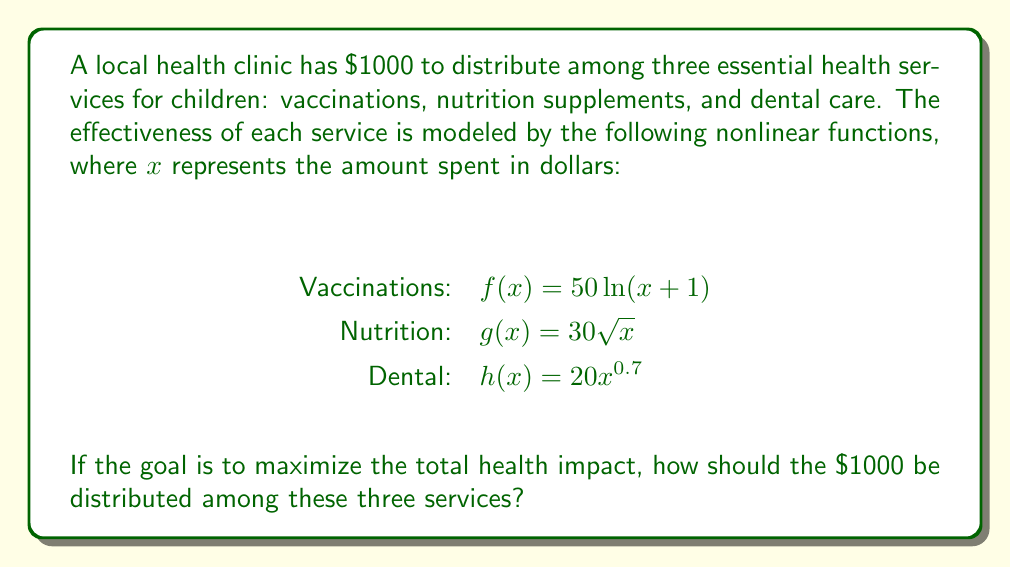Help me with this question. To solve this problem, we need to use the method of Lagrange multipliers to maximize the total health impact subject to the budget constraint.

Step 1: Define the objective function and constraint
Let $x$, $y$, and $z$ represent the amounts spent on vaccinations, nutrition, and dental care respectively.
Objective function: $F(x,y,z) = 50\ln(x+1) + 30\sqrt{y} + 20z^{0.7}$
Constraint: $G(x,y,z) = x + y + z - 1000 = 0$

Step 2: Form the Lagrangian
$$L(x,y,z,\lambda) = 50\ln(x+1) + 30\sqrt{y} + 20z^{0.7} + \lambda(x + y + z - 1000)$$

Step 3: Take partial derivatives and set them equal to zero
$$\frac{\partial L}{\partial x} = \frac{50}{x+1} + \lambda = 0$$
$$\frac{\partial L}{\partial y} = \frac{15}{\sqrt{y}} + \lambda = 0$$
$$\frac{\partial L}{\partial z} = \frac{14}{z^{0.3}} + \lambda = 0$$
$$\frac{\partial L}{\partial \lambda} = x + y + z - 1000 = 0$$

Step 4: Solve the system of equations
From the first three equations:
$$\frac{50}{x+1} = \frac{15}{\sqrt{y}} = \frac{14}{z^{0.3}} = -\lambda$$

Let $k = -\lambda$. Then:
$$x = \frac{50}{k} - 1$$
$$y = (\frac{15}{k})^2$$
$$z = (\frac{14}{k})^{\frac{10}{3}}$$

Substituting these into the constraint equation:
$$(\frac{50}{k} - 1) + (\frac{15}{k})^2 + (\frac{14}{k})^{\frac{10}{3}} = 1000$$

This equation can be solved numerically to find $k \approx 0.0739$.

Step 5: Calculate the optimal allocation
$$x \approx 676$$
$$y \approx 41$$
$$z \approx 283$$

Therefore, the optimal allocation is approximately $676 for vaccinations, $41 for nutrition supplements, and $283 for dental care.
Answer: Vaccinations: $676, Nutrition: $41, Dental: $283 